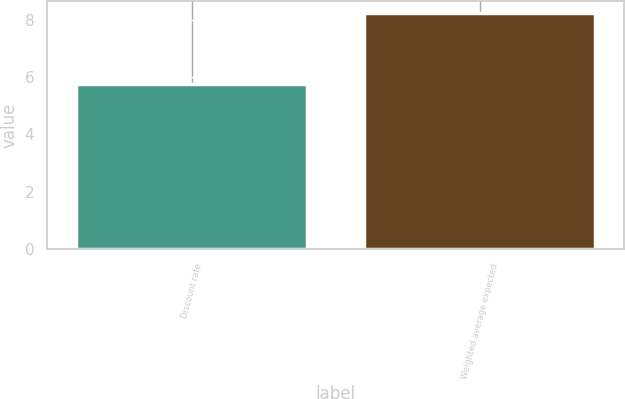<chart> <loc_0><loc_0><loc_500><loc_500><bar_chart><fcel>Discount rate<fcel>Weighted average expected<nl><fcel>5.75<fcel>8.25<nl></chart> 